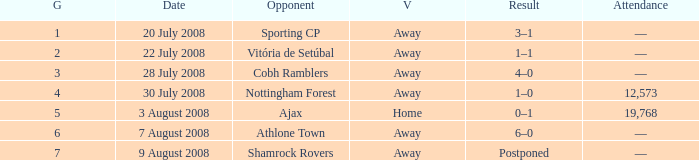What is the result of the game with a game number greater than 6 and an away venue? Postponed. 